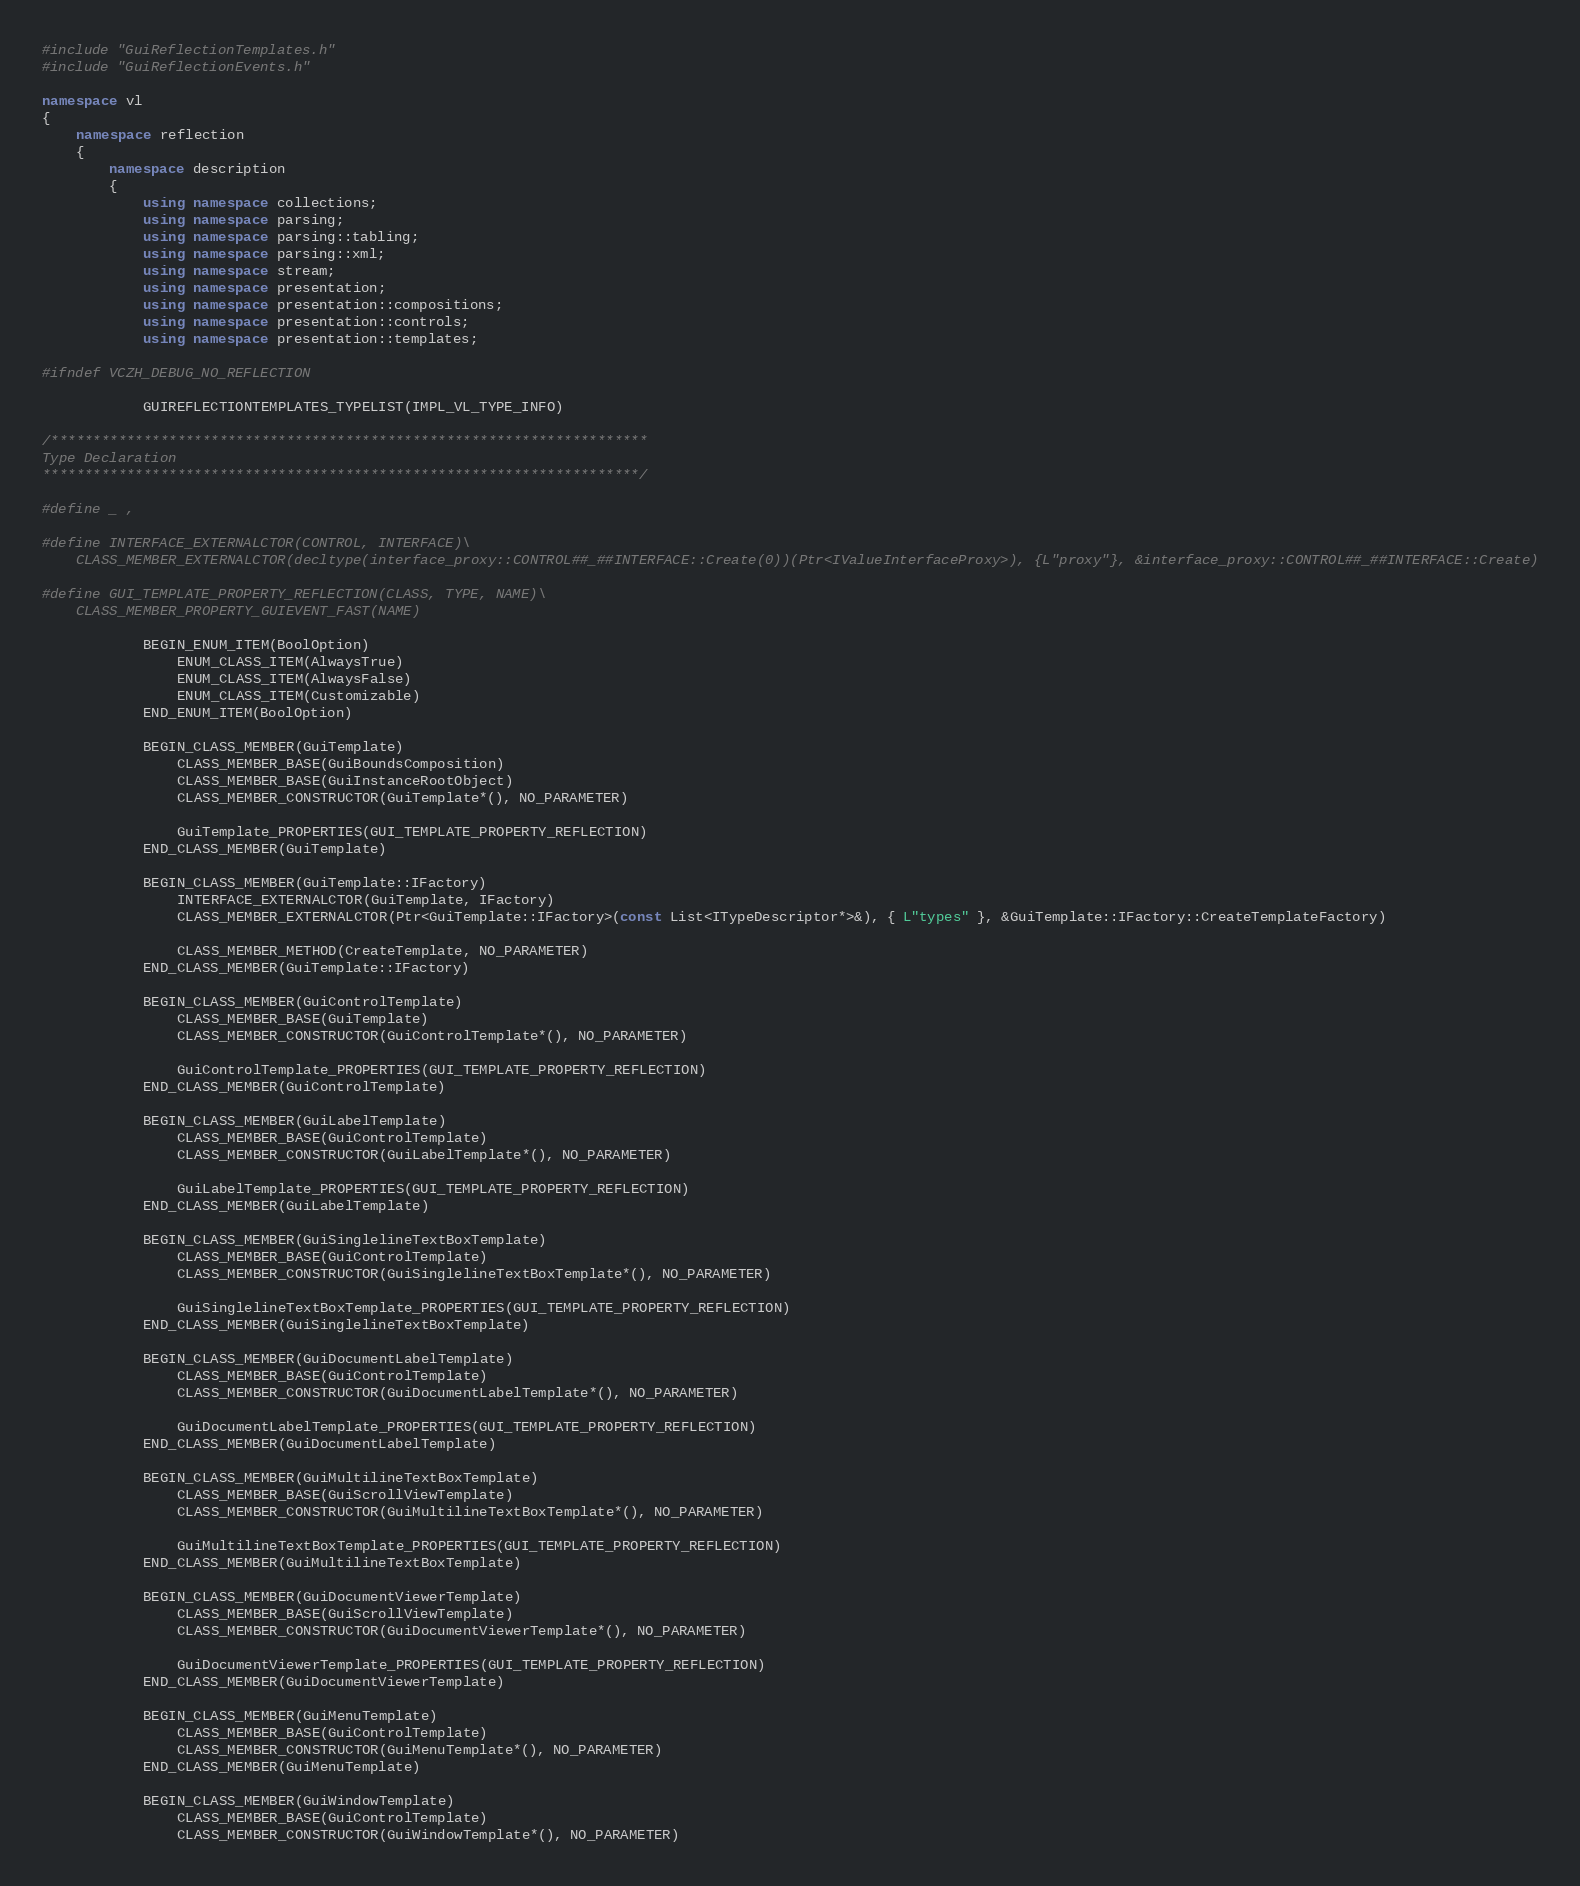Convert code to text. <code><loc_0><loc_0><loc_500><loc_500><_C++_>#include "GuiReflectionTemplates.h"
#include "GuiReflectionEvents.h"

namespace vl
{
	namespace reflection
	{
		namespace description
		{
			using namespace collections;
			using namespace parsing;
			using namespace parsing::tabling;
			using namespace parsing::xml;
			using namespace stream;
			using namespace presentation;
			using namespace presentation::compositions;
			using namespace presentation::controls;
			using namespace presentation::templates;

#ifndef VCZH_DEBUG_NO_REFLECTION

			GUIREFLECTIONTEMPLATES_TYPELIST(IMPL_VL_TYPE_INFO)

/***********************************************************************
Type Declaration
***********************************************************************/

#define _ ,

#define INTERFACE_EXTERNALCTOR(CONTROL, INTERFACE)\
	CLASS_MEMBER_EXTERNALCTOR(decltype(interface_proxy::CONTROL##_##INTERFACE::Create(0))(Ptr<IValueInterfaceProxy>), {L"proxy"}, &interface_proxy::CONTROL##_##INTERFACE::Create)

#define GUI_TEMPLATE_PROPERTY_REFLECTION(CLASS, TYPE, NAME)\
	CLASS_MEMBER_PROPERTY_GUIEVENT_FAST(NAME)

			BEGIN_ENUM_ITEM(BoolOption)
				ENUM_CLASS_ITEM(AlwaysTrue)
				ENUM_CLASS_ITEM(AlwaysFalse)
				ENUM_CLASS_ITEM(Customizable)
			END_ENUM_ITEM(BoolOption)

			BEGIN_CLASS_MEMBER(GuiTemplate)
				CLASS_MEMBER_BASE(GuiBoundsComposition)
				CLASS_MEMBER_BASE(GuiInstanceRootObject)
				CLASS_MEMBER_CONSTRUCTOR(GuiTemplate*(), NO_PARAMETER)

				GuiTemplate_PROPERTIES(GUI_TEMPLATE_PROPERTY_REFLECTION)
			END_CLASS_MEMBER(GuiTemplate)
			
			BEGIN_CLASS_MEMBER(GuiTemplate::IFactory)
				INTERFACE_EXTERNALCTOR(GuiTemplate, IFactory)
				CLASS_MEMBER_EXTERNALCTOR(Ptr<GuiTemplate::IFactory>(const List<ITypeDescriptor*>&), { L"types" }, &GuiTemplate::IFactory::CreateTemplateFactory)

				CLASS_MEMBER_METHOD(CreateTemplate, NO_PARAMETER)
			END_CLASS_MEMBER(GuiTemplate::IFactory)

			BEGIN_CLASS_MEMBER(GuiControlTemplate)
				CLASS_MEMBER_BASE(GuiTemplate)
				CLASS_MEMBER_CONSTRUCTOR(GuiControlTemplate*(), NO_PARAMETER)

				GuiControlTemplate_PROPERTIES(GUI_TEMPLATE_PROPERTY_REFLECTION)
			END_CLASS_MEMBER(GuiControlTemplate)

			BEGIN_CLASS_MEMBER(GuiLabelTemplate)
				CLASS_MEMBER_BASE(GuiControlTemplate)
				CLASS_MEMBER_CONSTRUCTOR(GuiLabelTemplate*(), NO_PARAMETER)

				GuiLabelTemplate_PROPERTIES(GUI_TEMPLATE_PROPERTY_REFLECTION)
			END_CLASS_MEMBER(GuiLabelTemplate)

			BEGIN_CLASS_MEMBER(GuiSinglelineTextBoxTemplate)
				CLASS_MEMBER_BASE(GuiControlTemplate)
				CLASS_MEMBER_CONSTRUCTOR(GuiSinglelineTextBoxTemplate*(), NO_PARAMETER)

				GuiSinglelineTextBoxTemplate_PROPERTIES(GUI_TEMPLATE_PROPERTY_REFLECTION)
			END_CLASS_MEMBER(GuiSinglelineTextBoxTemplate)

			BEGIN_CLASS_MEMBER(GuiDocumentLabelTemplate)
				CLASS_MEMBER_BASE(GuiControlTemplate)
				CLASS_MEMBER_CONSTRUCTOR(GuiDocumentLabelTemplate*(), NO_PARAMETER)

				GuiDocumentLabelTemplate_PROPERTIES(GUI_TEMPLATE_PROPERTY_REFLECTION)
			END_CLASS_MEMBER(GuiDocumentLabelTemplate)

			BEGIN_CLASS_MEMBER(GuiMultilineTextBoxTemplate)
				CLASS_MEMBER_BASE(GuiScrollViewTemplate)
				CLASS_MEMBER_CONSTRUCTOR(GuiMultilineTextBoxTemplate*(), NO_PARAMETER)

				GuiMultilineTextBoxTemplate_PROPERTIES(GUI_TEMPLATE_PROPERTY_REFLECTION)
			END_CLASS_MEMBER(GuiMultilineTextBoxTemplate)

			BEGIN_CLASS_MEMBER(GuiDocumentViewerTemplate)
				CLASS_MEMBER_BASE(GuiScrollViewTemplate)
				CLASS_MEMBER_CONSTRUCTOR(GuiDocumentViewerTemplate*(), NO_PARAMETER)

				GuiDocumentViewerTemplate_PROPERTIES(GUI_TEMPLATE_PROPERTY_REFLECTION)
			END_CLASS_MEMBER(GuiDocumentViewerTemplate)

			BEGIN_CLASS_MEMBER(GuiMenuTemplate)
				CLASS_MEMBER_BASE(GuiControlTemplate)
				CLASS_MEMBER_CONSTRUCTOR(GuiMenuTemplate*(), NO_PARAMETER)
			END_CLASS_MEMBER(GuiMenuTemplate)

			BEGIN_CLASS_MEMBER(GuiWindowTemplate)
				CLASS_MEMBER_BASE(GuiControlTemplate)
				CLASS_MEMBER_CONSTRUCTOR(GuiWindowTemplate*(), NO_PARAMETER)
</code> 